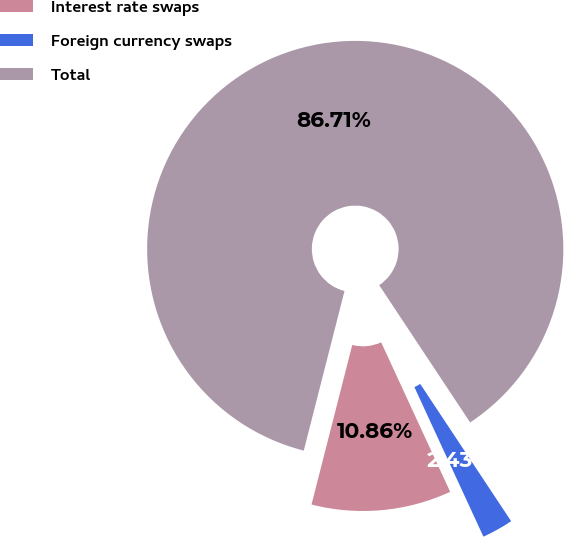Convert chart. <chart><loc_0><loc_0><loc_500><loc_500><pie_chart><fcel>Interest rate swaps<fcel>Foreign currency swaps<fcel>Total<nl><fcel>10.86%<fcel>2.43%<fcel>86.71%<nl></chart> 